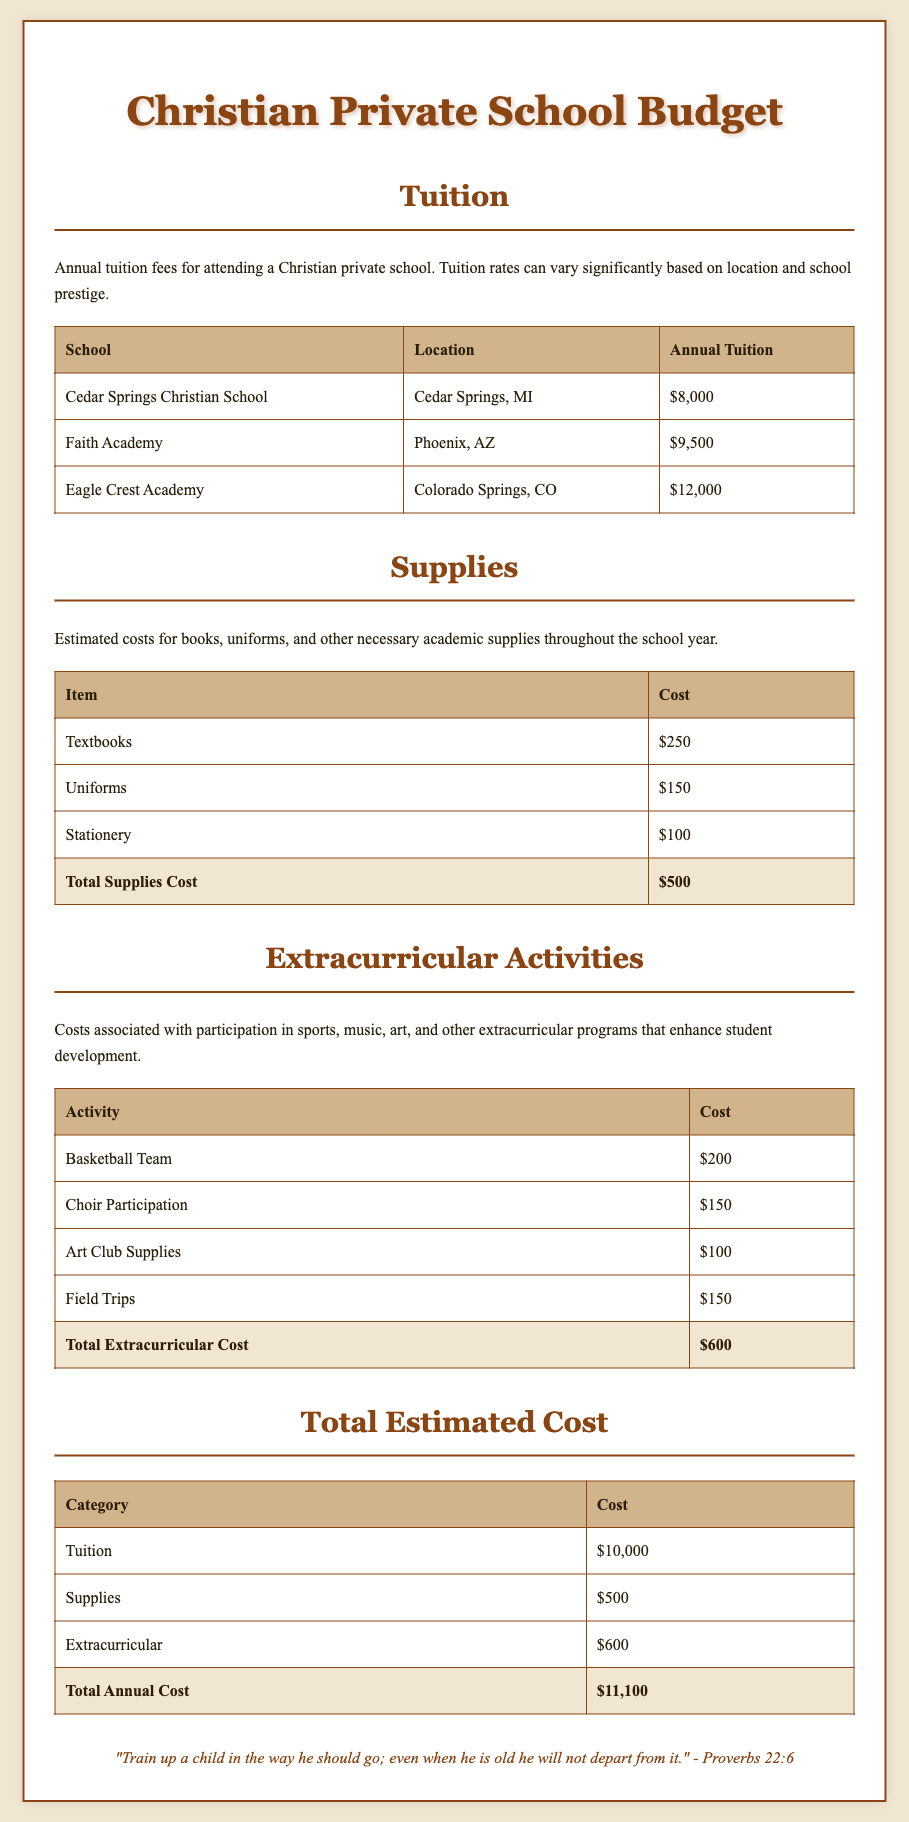What is the annual tuition for Cedar Springs Christian School? The annual tuition for Cedar Springs Christian School is listed in the document, which specifies it as $8,000.
Answer: $8,000 What is the total cost of supplies? The total cost of supplies is calculated from the individual item costs and is shown in the document as $500.
Answer: $500 How much does choir participation cost? The document includes a specific cost for choir participation, which is $150.
Answer: $150 What is the total annual cost for attending this Christian private school? The total annual cost is the sum of tuition, supplies, and extracurricular expenses listed in the document, which is $11,100.
Answer: $11,100 How much does participation in the basketball team cost? The document states that participation in the basketball team costs $200.
Answer: $200 What school has the highest tuition? The document provides tuition rates for different schools, and Eagle Crest Academy has the highest tuition at $12,000.
Answer: Eagle Crest Academy What percentage of the total cost is made up by tuition? The total cost is $11,100, with tuition being $10,000; therefore, tuition makes up approximately 90% of the total cost.
Answer: 90% What items are included in the supplies category? The supplies category includes textbooks, uniforms, and stationery, as listed in the document.
Answer: Textbooks, uniforms, stationery What is the cost of field trips? The document specifies the cost for field trips as $150.
Answer: $150 